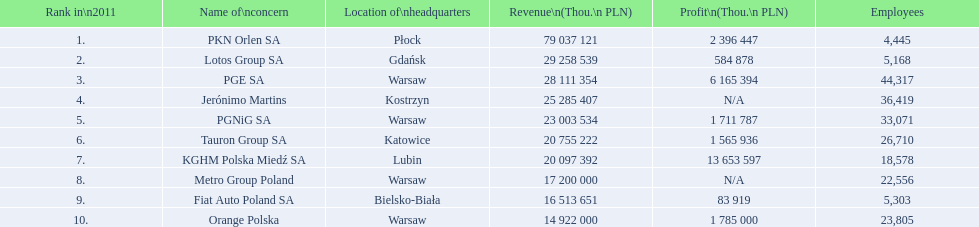How many companies had over $1,000,000 profit? 6. 